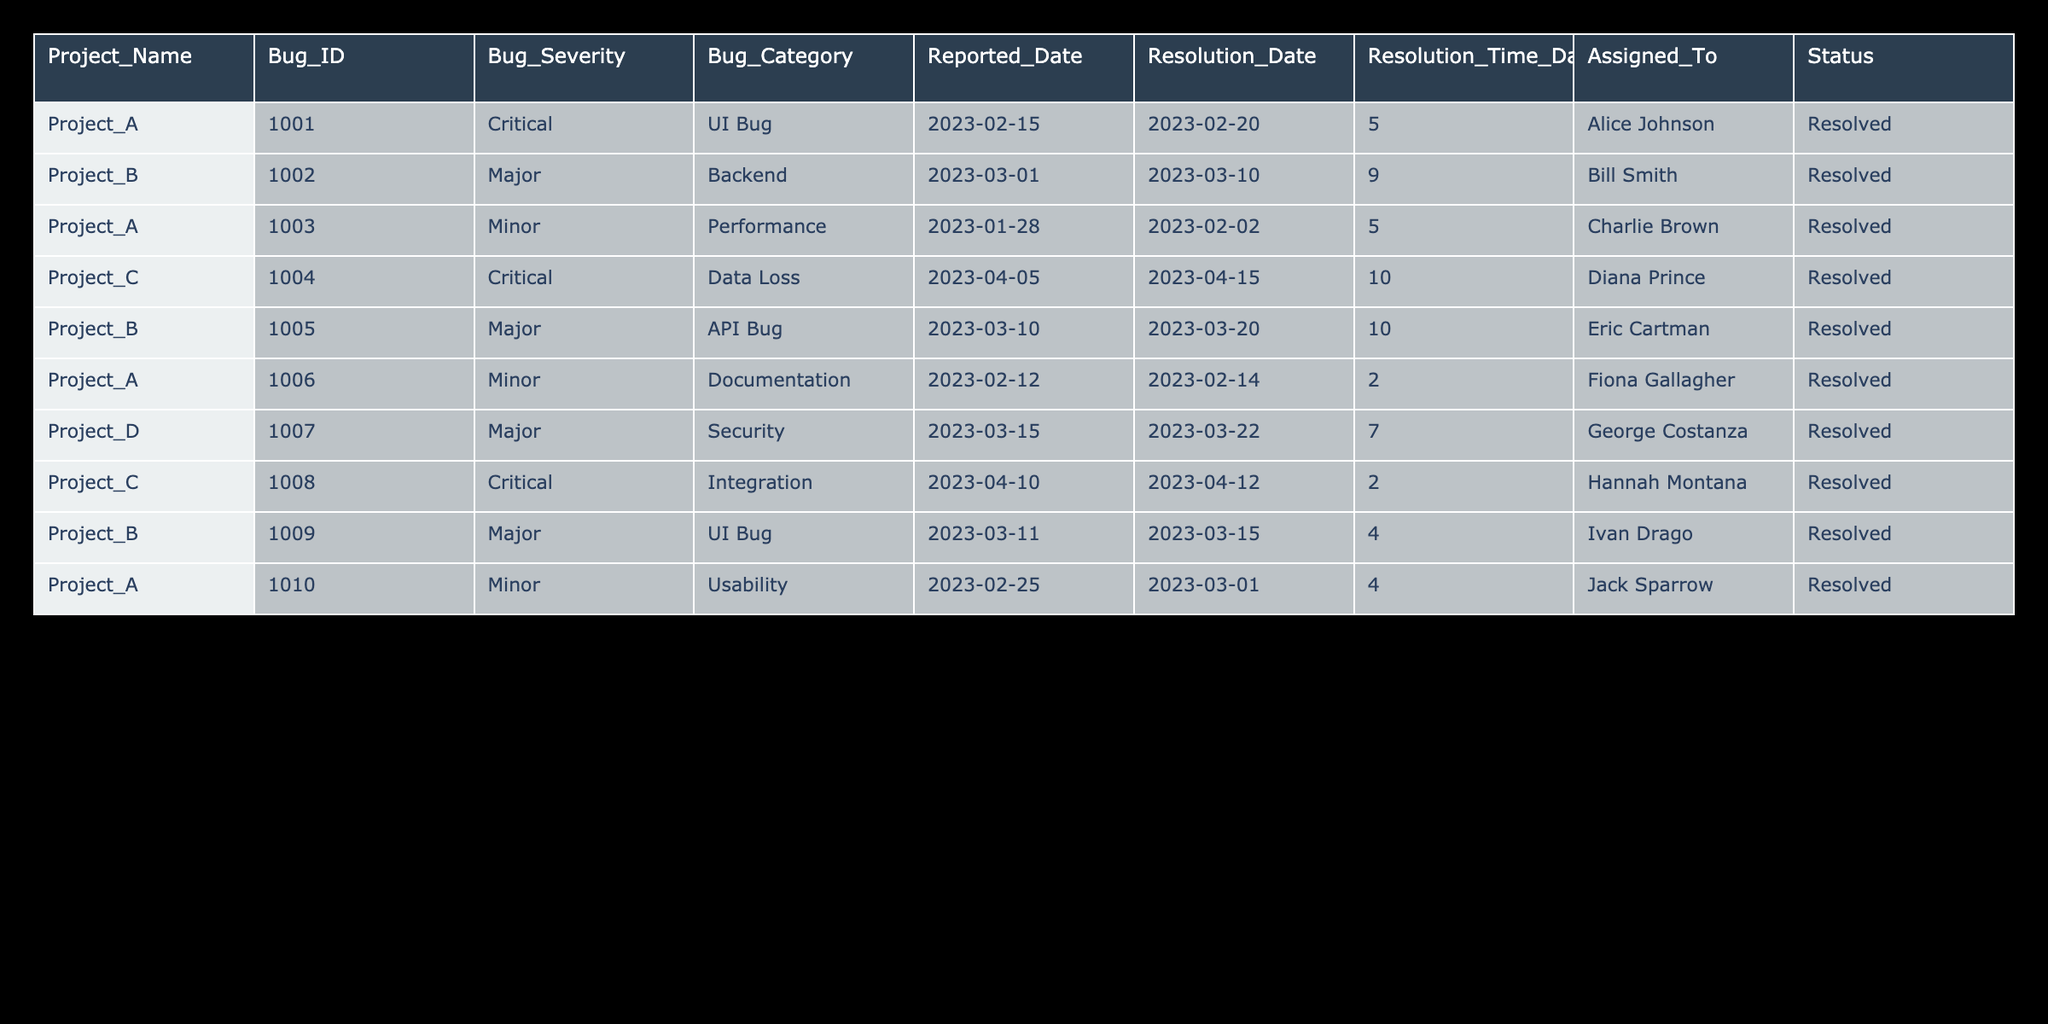What is the total number of bugs reported in Project A? Project A has three bugs: Bug ID 1001, Bug ID 1003, and Bug ID 1010. Therefore, the total number of bugs reported in Project A is 3.
Answer: 3 What is the average resolution time for all bugs in the table? The resolution times are 5, 9, 5, 10, 10, 2, 7, 2, 4, and 4 days. Summing these gives 54 days and since there are 10 bugs, the average resolution time is 54/10 = 5.4 days.
Answer: 5.4 days Is there any bug reported in Project C with a critical severity? There are two bugs reported in Project C, with Bug ID 1004 being critical and Bug ID 1008 also being critical. Therefore, the statement is true.
Answer: Yes Which project has the longest single bug resolution time, and how long was it? From the table, Project C has the longest bug resolution time of 10 days for Bug ID 1004. This is the maximum value compared to other projects.
Answer: Project C, 10 days What percentage of the reported bugs were classified as critical? There are 10 total bugs, out of which 3 are classified as critical (IDs 1001, 1004, and 1008). Calculating the percentage gives (3/10) * 100 = 30%.
Answer: 30% 